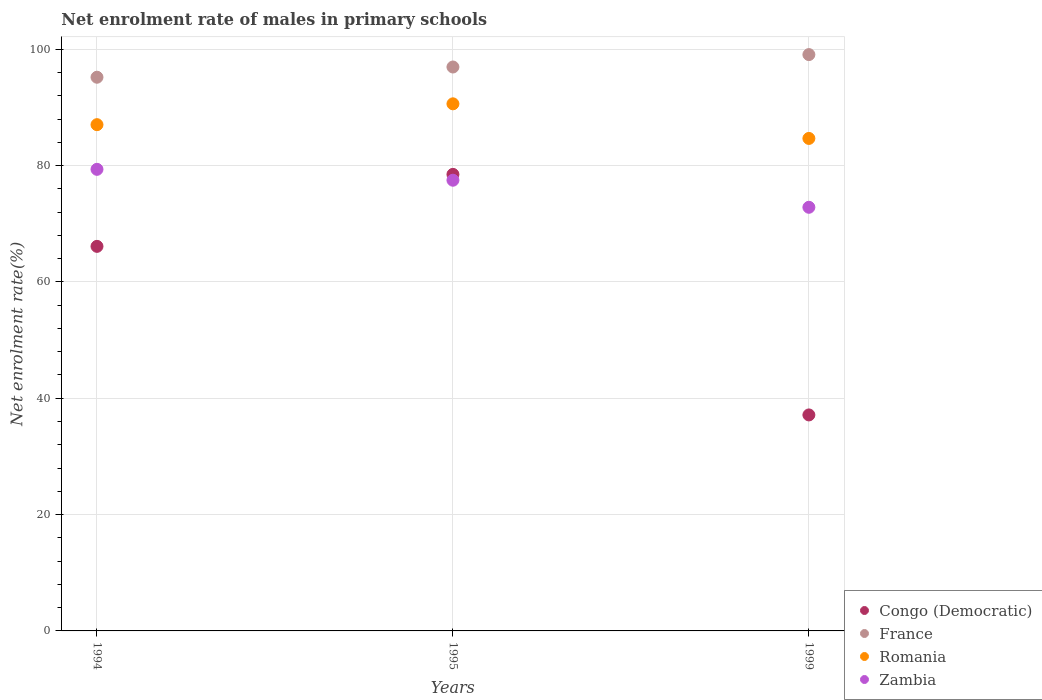What is the net enrolment rate of males in primary schools in Zambia in 1999?
Offer a terse response. 72.83. Across all years, what is the maximum net enrolment rate of males in primary schools in Romania?
Offer a very short reply. 90.62. Across all years, what is the minimum net enrolment rate of males in primary schools in Romania?
Ensure brevity in your answer.  84.67. In which year was the net enrolment rate of males in primary schools in Romania maximum?
Offer a very short reply. 1995. What is the total net enrolment rate of males in primary schools in France in the graph?
Provide a succinct answer. 291.23. What is the difference between the net enrolment rate of males in primary schools in Congo (Democratic) in 1995 and that in 1999?
Your answer should be compact. 41.36. What is the difference between the net enrolment rate of males in primary schools in Romania in 1994 and the net enrolment rate of males in primary schools in France in 1999?
Your answer should be very brief. -12.05. What is the average net enrolment rate of males in primary schools in Romania per year?
Provide a short and direct response. 87.44. In the year 1994, what is the difference between the net enrolment rate of males in primary schools in Congo (Democratic) and net enrolment rate of males in primary schools in Romania?
Provide a short and direct response. -20.92. In how many years, is the net enrolment rate of males in primary schools in France greater than 44 %?
Give a very brief answer. 3. What is the ratio of the net enrolment rate of males in primary schools in Zambia in 1994 to that in 1999?
Keep it short and to the point. 1.09. Is the net enrolment rate of males in primary schools in Romania in 1995 less than that in 1999?
Your response must be concise. No. What is the difference between the highest and the second highest net enrolment rate of males in primary schools in Romania?
Ensure brevity in your answer.  3.58. What is the difference between the highest and the lowest net enrolment rate of males in primary schools in Romania?
Make the answer very short. 5.95. In how many years, is the net enrolment rate of males in primary schools in Romania greater than the average net enrolment rate of males in primary schools in Romania taken over all years?
Provide a short and direct response. 1. Is the sum of the net enrolment rate of males in primary schools in Zambia in 1995 and 1999 greater than the maximum net enrolment rate of males in primary schools in Romania across all years?
Provide a short and direct response. Yes. Is it the case that in every year, the sum of the net enrolment rate of males in primary schools in Zambia and net enrolment rate of males in primary schools in Romania  is greater than the sum of net enrolment rate of males in primary schools in Congo (Democratic) and net enrolment rate of males in primary schools in France?
Make the answer very short. No. Is it the case that in every year, the sum of the net enrolment rate of males in primary schools in France and net enrolment rate of males in primary schools in Romania  is greater than the net enrolment rate of males in primary schools in Congo (Democratic)?
Your answer should be compact. Yes. Does the net enrolment rate of males in primary schools in Congo (Democratic) monotonically increase over the years?
Your answer should be compact. No. Is the net enrolment rate of males in primary schools in Romania strictly greater than the net enrolment rate of males in primary schools in Congo (Democratic) over the years?
Provide a succinct answer. Yes. How many dotlines are there?
Keep it short and to the point. 4. How many years are there in the graph?
Give a very brief answer. 3. Are the values on the major ticks of Y-axis written in scientific E-notation?
Your answer should be compact. No. Does the graph contain grids?
Offer a very short reply. Yes. How many legend labels are there?
Provide a short and direct response. 4. How are the legend labels stacked?
Make the answer very short. Vertical. What is the title of the graph?
Provide a succinct answer. Net enrolment rate of males in primary schools. What is the label or title of the X-axis?
Provide a succinct answer. Years. What is the label or title of the Y-axis?
Ensure brevity in your answer.  Net enrolment rate(%). What is the Net enrolment rate(%) of Congo (Democratic) in 1994?
Offer a terse response. 66.12. What is the Net enrolment rate(%) in France in 1994?
Give a very brief answer. 95.19. What is the Net enrolment rate(%) in Romania in 1994?
Provide a succinct answer. 87.04. What is the Net enrolment rate(%) in Zambia in 1994?
Your answer should be compact. 79.36. What is the Net enrolment rate(%) in Congo (Democratic) in 1995?
Keep it short and to the point. 78.49. What is the Net enrolment rate(%) of France in 1995?
Offer a terse response. 96.95. What is the Net enrolment rate(%) of Romania in 1995?
Offer a very short reply. 90.62. What is the Net enrolment rate(%) in Zambia in 1995?
Your answer should be compact. 77.49. What is the Net enrolment rate(%) in Congo (Democratic) in 1999?
Give a very brief answer. 37.14. What is the Net enrolment rate(%) in France in 1999?
Your response must be concise. 99.09. What is the Net enrolment rate(%) in Romania in 1999?
Make the answer very short. 84.67. What is the Net enrolment rate(%) of Zambia in 1999?
Your response must be concise. 72.83. Across all years, what is the maximum Net enrolment rate(%) of Congo (Democratic)?
Provide a short and direct response. 78.49. Across all years, what is the maximum Net enrolment rate(%) of France?
Offer a very short reply. 99.09. Across all years, what is the maximum Net enrolment rate(%) of Romania?
Ensure brevity in your answer.  90.62. Across all years, what is the maximum Net enrolment rate(%) in Zambia?
Keep it short and to the point. 79.36. Across all years, what is the minimum Net enrolment rate(%) of Congo (Democratic)?
Offer a terse response. 37.14. Across all years, what is the minimum Net enrolment rate(%) in France?
Your response must be concise. 95.19. Across all years, what is the minimum Net enrolment rate(%) in Romania?
Keep it short and to the point. 84.67. Across all years, what is the minimum Net enrolment rate(%) of Zambia?
Your answer should be very brief. 72.83. What is the total Net enrolment rate(%) in Congo (Democratic) in the graph?
Offer a terse response. 181.74. What is the total Net enrolment rate(%) in France in the graph?
Your answer should be very brief. 291.23. What is the total Net enrolment rate(%) in Romania in the graph?
Provide a short and direct response. 262.33. What is the total Net enrolment rate(%) in Zambia in the graph?
Give a very brief answer. 229.68. What is the difference between the Net enrolment rate(%) of Congo (Democratic) in 1994 and that in 1995?
Give a very brief answer. -12.38. What is the difference between the Net enrolment rate(%) of France in 1994 and that in 1995?
Give a very brief answer. -1.76. What is the difference between the Net enrolment rate(%) in Romania in 1994 and that in 1995?
Keep it short and to the point. -3.58. What is the difference between the Net enrolment rate(%) of Zambia in 1994 and that in 1995?
Ensure brevity in your answer.  1.87. What is the difference between the Net enrolment rate(%) in Congo (Democratic) in 1994 and that in 1999?
Offer a very short reply. 28.98. What is the difference between the Net enrolment rate(%) in France in 1994 and that in 1999?
Offer a terse response. -3.89. What is the difference between the Net enrolment rate(%) in Romania in 1994 and that in 1999?
Offer a terse response. 2.37. What is the difference between the Net enrolment rate(%) in Zambia in 1994 and that in 1999?
Your answer should be very brief. 6.53. What is the difference between the Net enrolment rate(%) of Congo (Democratic) in 1995 and that in 1999?
Provide a short and direct response. 41.36. What is the difference between the Net enrolment rate(%) of France in 1995 and that in 1999?
Your answer should be compact. -2.13. What is the difference between the Net enrolment rate(%) of Romania in 1995 and that in 1999?
Your answer should be compact. 5.95. What is the difference between the Net enrolment rate(%) of Zambia in 1995 and that in 1999?
Make the answer very short. 4.65. What is the difference between the Net enrolment rate(%) of Congo (Democratic) in 1994 and the Net enrolment rate(%) of France in 1995?
Offer a very short reply. -30.84. What is the difference between the Net enrolment rate(%) in Congo (Democratic) in 1994 and the Net enrolment rate(%) in Romania in 1995?
Provide a short and direct response. -24.5. What is the difference between the Net enrolment rate(%) in Congo (Democratic) in 1994 and the Net enrolment rate(%) in Zambia in 1995?
Provide a succinct answer. -11.37. What is the difference between the Net enrolment rate(%) in France in 1994 and the Net enrolment rate(%) in Romania in 1995?
Provide a short and direct response. 4.57. What is the difference between the Net enrolment rate(%) in France in 1994 and the Net enrolment rate(%) in Zambia in 1995?
Provide a succinct answer. 17.71. What is the difference between the Net enrolment rate(%) in Romania in 1994 and the Net enrolment rate(%) in Zambia in 1995?
Your response must be concise. 9.55. What is the difference between the Net enrolment rate(%) in Congo (Democratic) in 1994 and the Net enrolment rate(%) in France in 1999?
Give a very brief answer. -32.97. What is the difference between the Net enrolment rate(%) of Congo (Democratic) in 1994 and the Net enrolment rate(%) of Romania in 1999?
Give a very brief answer. -18.55. What is the difference between the Net enrolment rate(%) of Congo (Democratic) in 1994 and the Net enrolment rate(%) of Zambia in 1999?
Your response must be concise. -6.72. What is the difference between the Net enrolment rate(%) of France in 1994 and the Net enrolment rate(%) of Romania in 1999?
Provide a succinct answer. 10.52. What is the difference between the Net enrolment rate(%) in France in 1994 and the Net enrolment rate(%) in Zambia in 1999?
Provide a succinct answer. 22.36. What is the difference between the Net enrolment rate(%) in Romania in 1994 and the Net enrolment rate(%) in Zambia in 1999?
Your response must be concise. 14.21. What is the difference between the Net enrolment rate(%) in Congo (Democratic) in 1995 and the Net enrolment rate(%) in France in 1999?
Give a very brief answer. -20.59. What is the difference between the Net enrolment rate(%) in Congo (Democratic) in 1995 and the Net enrolment rate(%) in Romania in 1999?
Provide a succinct answer. -6.18. What is the difference between the Net enrolment rate(%) of Congo (Democratic) in 1995 and the Net enrolment rate(%) of Zambia in 1999?
Your answer should be compact. 5.66. What is the difference between the Net enrolment rate(%) in France in 1995 and the Net enrolment rate(%) in Romania in 1999?
Keep it short and to the point. 12.28. What is the difference between the Net enrolment rate(%) in France in 1995 and the Net enrolment rate(%) in Zambia in 1999?
Keep it short and to the point. 24.12. What is the difference between the Net enrolment rate(%) of Romania in 1995 and the Net enrolment rate(%) of Zambia in 1999?
Provide a succinct answer. 17.79. What is the average Net enrolment rate(%) of Congo (Democratic) per year?
Offer a terse response. 60.58. What is the average Net enrolment rate(%) of France per year?
Provide a succinct answer. 97.08. What is the average Net enrolment rate(%) in Romania per year?
Make the answer very short. 87.44. What is the average Net enrolment rate(%) in Zambia per year?
Ensure brevity in your answer.  76.56. In the year 1994, what is the difference between the Net enrolment rate(%) in Congo (Democratic) and Net enrolment rate(%) in France?
Ensure brevity in your answer.  -29.08. In the year 1994, what is the difference between the Net enrolment rate(%) in Congo (Democratic) and Net enrolment rate(%) in Romania?
Your answer should be very brief. -20.92. In the year 1994, what is the difference between the Net enrolment rate(%) in Congo (Democratic) and Net enrolment rate(%) in Zambia?
Offer a terse response. -13.24. In the year 1994, what is the difference between the Net enrolment rate(%) of France and Net enrolment rate(%) of Romania?
Ensure brevity in your answer.  8.16. In the year 1994, what is the difference between the Net enrolment rate(%) of France and Net enrolment rate(%) of Zambia?
Provide a succinct answer. 15.83. In the year 1994, what is the difference between the Net enrolment rate(%) of Romania and Net enrolment rate(%) of Zambia?
Make the answer very short. 7.68. In the year 1995, what is the difference between the Net enrolment rate(%) in Congo (Democratic) and Net enrolment rate(%) in France?
Provide a short and direct response. -18.46. In the year 1995, what is the difference between the Net enrolment rate(%) of Congo (Democratic) and Net enrolment rate(%) of Romania?
Your response must be concise. -12.13. In the year 1995, what is the difference between the Net enrolment rate(%) of Congo (Democratic) and Net enrolment rate(%) of Zambia?
Provide a short and direct response. 1. In the year 1995, what is the difference between the Net enrolment rate(%) in France and Net enrolment rate(%) in Romania?
Offer a very short reply. 6.33. In the year 1995, what is the difference between the Net enrolment rate(%) of France and Net enrolment rate(%) of Zambia?
Offer a terse response. 19.46. In the year 1995, what is the difference between the Net enrolment rate(%) of Romania and Net enrolment rate(%) of Zambia?
Your answer should be very brief. 13.13. In the year 1999, what is the difference between the Net enrolment rate(%) in Congo (Democratic) and Net enrolment rate(%) in France?
Ensure brevity in your answer.  -61.95. In the year 1999, what is the difference between the Net enrolment rate(%) of Congo (Democratic) and Net enrolment rate(%) of Romania?
Keep it short and to the point. -47.54. In the year 1999, what is the difference between the Net enrolment rate(%) in Congo (Democratic) and Net enrolment rate(%) in Zambia?
Offer a very short reply. -35.7. In the year 1999, what is the difference between the Net enrolment rate(%) in France and Net enrolment rate(%) in Romania?
Provide a succinct answer. 14.41. In the year 1999, what is the difference between the Net enrolment rate(%) of France and Net enrolment rate(%) of Zambia?
Provide a short and direct response. 26.25. In the year 1999, what is the difference between the Net enrolment rate(%) in Romania and Net enrolment rate(%) in Zambia?
Your answer should be very brief. 11.84. What is the ratio of the Net enrolment rate(%) of Congo (Democratic) in 1994 to that in 1995?
Ensure brevity in your answer.  0.84. What is the ratio of the Net enrolment rate(%) in France in 1994 to that in 1995?
Give a very brief answer. 0.98. What is the ratio of the Net enrolment rate(%) of Romania in 1994 to that in 1995?
Offer a terse response. 0.96. What is the ratio of the Net enrolment rate(%) in Zambia in 1994 to that in 1995?
Make the answer very short. 1.02. What is the ratio of the Net enrolment rate(%) of Congo (Democratic) in 1994 to that in 1999?
Your answer should be very brief. 1.78. What is the ratio of the Net enrolment rate(%) of France in 1994 to that in 1999?
Provide a succinct answer. 0.96. What is the ratio of the Net enrolment rate(%) of Romania in 1994 to that in 1999?
Offer a very short reply. 1.03. What is the ratio of the Net enrolment rate(%) in Zambia in 1994 to that in 1999?
Provide a short and direct response. 1.09. What is the ratio of the Net enrolment rate(%) of Congo (Democratic) in 1995 to that in 1999?
Your response must be concise. 2.11. What is the ratio of the Net enrolment rate(%) of France in 1995 to that in 1999?
Keep it short and to the point. 0.98. What is the ratio of the Net enrolment rate(%) of Romania in 1995 to that in 1999?
Offer a very short reply. 1.07. What is the ratio of the Net enrolment rate(%) in Zambia in 1995 to that in 1999?
Ensure brevity in your answer.  1.06. What is the difference between the highest and the second highest Net enrolment rate(%) of Congo (Democratic)?
Make the answer very short. 12.38. What is the difference between the highest and the second highest Net enrolment rate(%) of France?
Make the answer very short. 2.13. What is the difference between the highest and the second highest Net enrolment rate(%) in Romania?
Give a very brief answer. 3.58. What is the difference between the highest and the second highest Net enrolment rate(%) of Zambia?
Your answer should be compact. 1.87. What is the difference between the highest and the lowest Net enrolment rate(%) in Congo (Democratic)?
Make the answer very short. 41.36. What is the difference between the highest and the lowest Net enrolment rate(%) in France?
Make the answer very short. 3.89. What is the difference between the highest and the lowest Net enrolment rate(%) of Romania?
Give a very brief answer. 5.95. What is the difference between the highest and the lowest Net enrolment rate(%) in Zambia?
Provide a short and direct response. 6.53. 